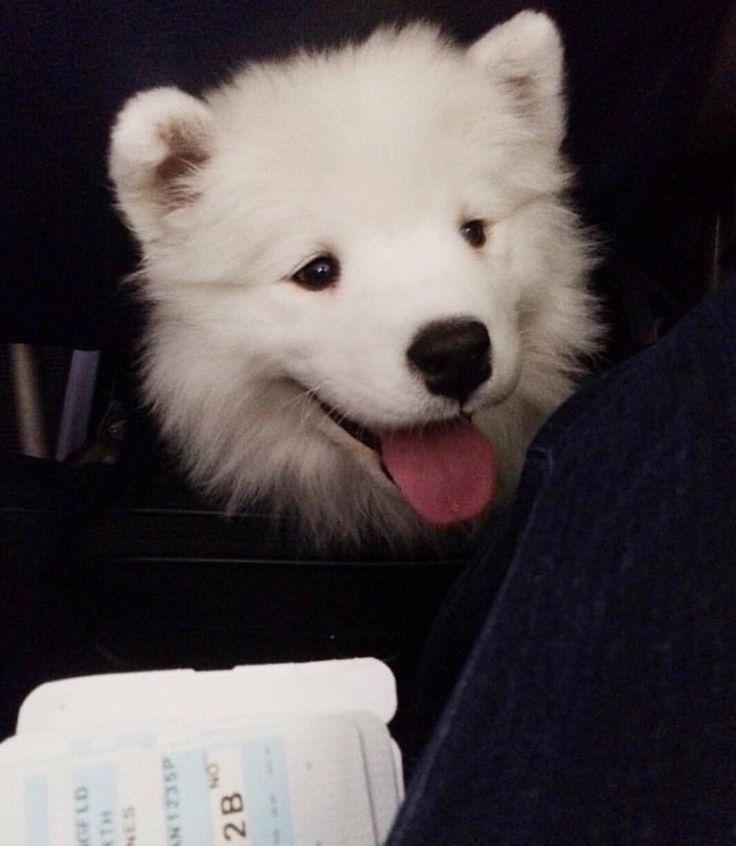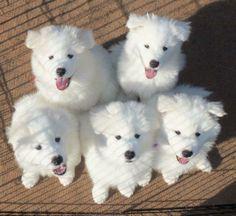The first image is the image on the left, the second image is the image on the right. For the images shown, is this caption "There are no more than three dogs and one of them has it's mouth open." true? Answer yes or no. No. The first image is the image on the left, the second image is the image on the right. Given the left and right images, does the statement "We have no more than three dogs in total." hold true? Answer yes or no. No. 